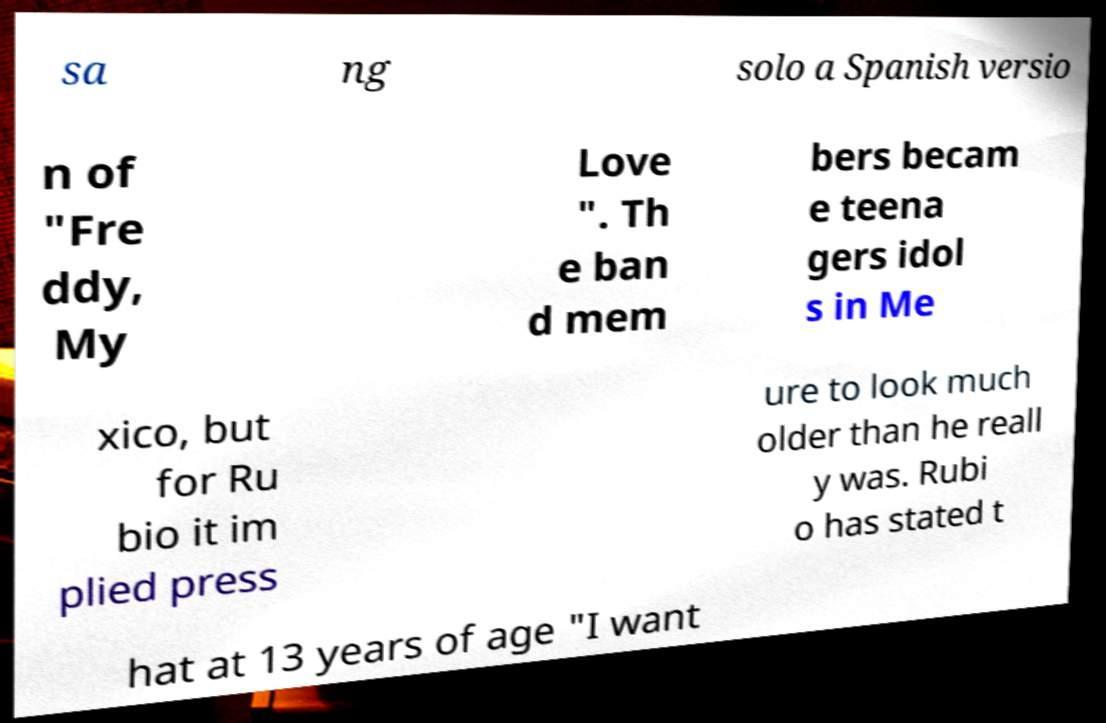For documentation purposes, I need the text within this image transcribed. Could you provide that? sa ng solo a Spanish versio n of "Fre ddy, My Love ". Th e ban d mem bers becam e teena gers idol s in Me xico, but for Ru bio it im plied press ure to look much older than he reall y was. Rubi o has stated t hat at 13 years of age "I want 